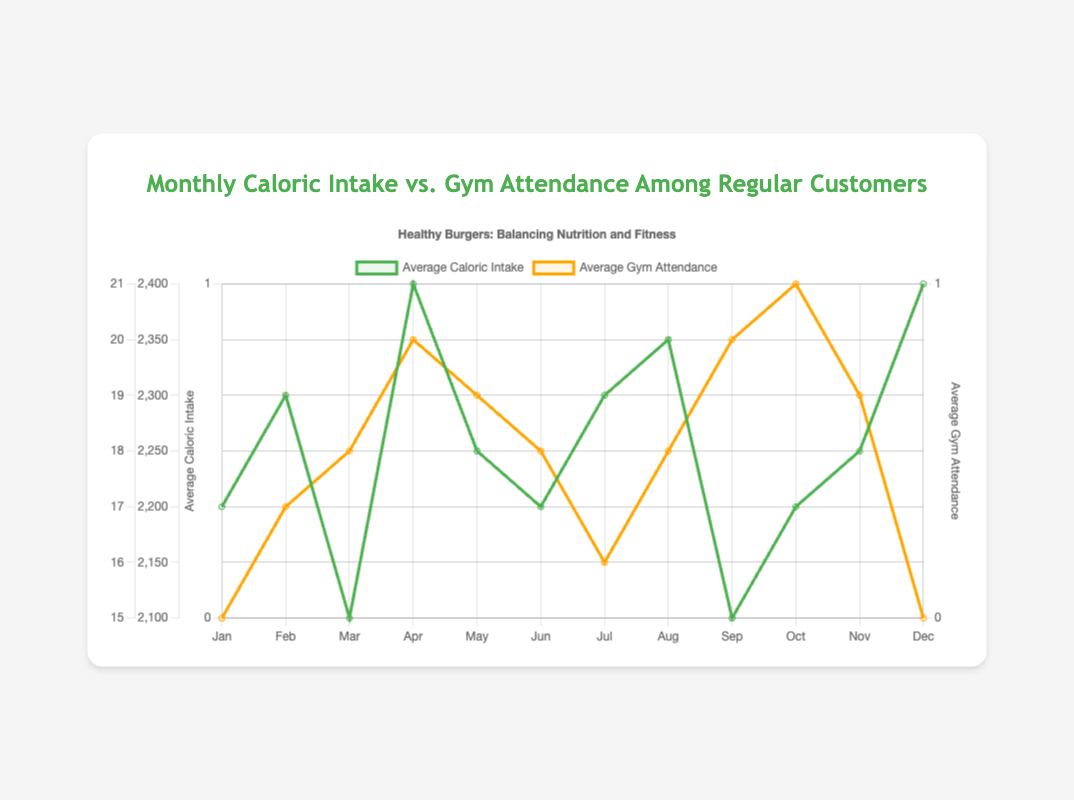Which month has the highest average caloric intake? By looking at the green line (Average Caloric Intake), the highest point corresponds to April and December, both with a value of 2400
Answer: April and December Which month has the lowest gym attendance? By observing the orange line (Average Gym Attendance), the lowest point is in January and December, both with a gym attendance of 15
Answer: January and December What's the combined caloric intake for January and February? The caloric intake for January is 2200 and for February is 2300. The combined value is 2200 + 2300 = 4500
Answer: 4500 Is there a month where the caloric intake exceeds 2300 and gym attendance exceeds 18? By examining the data points, April has an average caloric intake of 2400 and gym attendance of 20, which both exceed 2300 and 18 respectively
Answer: April How many months have an average gym attendance of 18 or more? Count the months with gym attendance values of 18 or more: March (18), April (20), May (19), June (18), August (18), September (20), October (21), November (19). That's 8 months in total
Answer: 8 What's the difference in gym attendance between the month with the highest gym attendance and the month with the lowest gym attendance? The highest gym attendance is in October (21) and the lowest is in January and December, both at 15. The difference is 21 - 15 = 6
Answer: 6 Which months both exceed 2200 in average caloric intake and also have gym attendance less than 19? By analyzing the data, February (2300 and 17) and July (2300 and 16) both meet these criteria
Answer: February and July How does the caloric intake in March compare to April? The caloric intake in March is 2100, while in April it is 2400. Comparing these values, April's caloric intake is higher by 300 units
Answer: Higher by 300 units In which month do both caloric intake and gym attendance peak? The caloric intake peaks in April and December, but only April also has a peak in gym attendance (20 in April)
Answer: April What's the average gym attendance over the entire year? Sum all monthly gym attendances and divide by 12: (15 + 17 + 18 + 20 + 19 + 18 + 16 + 18 + 20 + 21 + 19 + 15) / 12 = 18
Answer: 18 